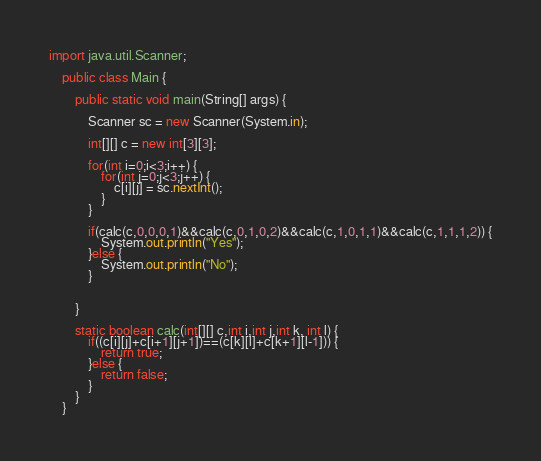Convert code to text. <code><loc_0><loc_0><loc_500><loc_500><_Java_>import java.util.Scanner;

	public class Main {

		public static void main(String[] args) {

			Scanner sc = new Scanner(System.in);
			
			int[][] c = new int[3][3];
			
			for(int i=0;i<3;i++) {
				for(int j=0;j<3;j++) {
					c[i][j] = sc.nextInt();
				}
			}
			
			if(calc(c,0,0,0,1)&&calc(c,0,1,0,2)&&calc(c,1,0,1,1)&&calc(c,1,1,1,2)) {
				System.out.println("Yes");
			}else {
				System.out.println("No");
			}
			
			
	    }
		
		static boolean calc(int[][] c,int i,int j,int k, int l) {
			if((c[i][j]+c[i+1][j+1])==(c[k][l]+c[k+1][l-1])) {
				return true;
			}else {
				return false;
			}
		}
	}
</code> 